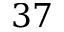Convert formula to latex. <formula><loc_0><loc_0><loc_500><loc_500>3 7</formula> 